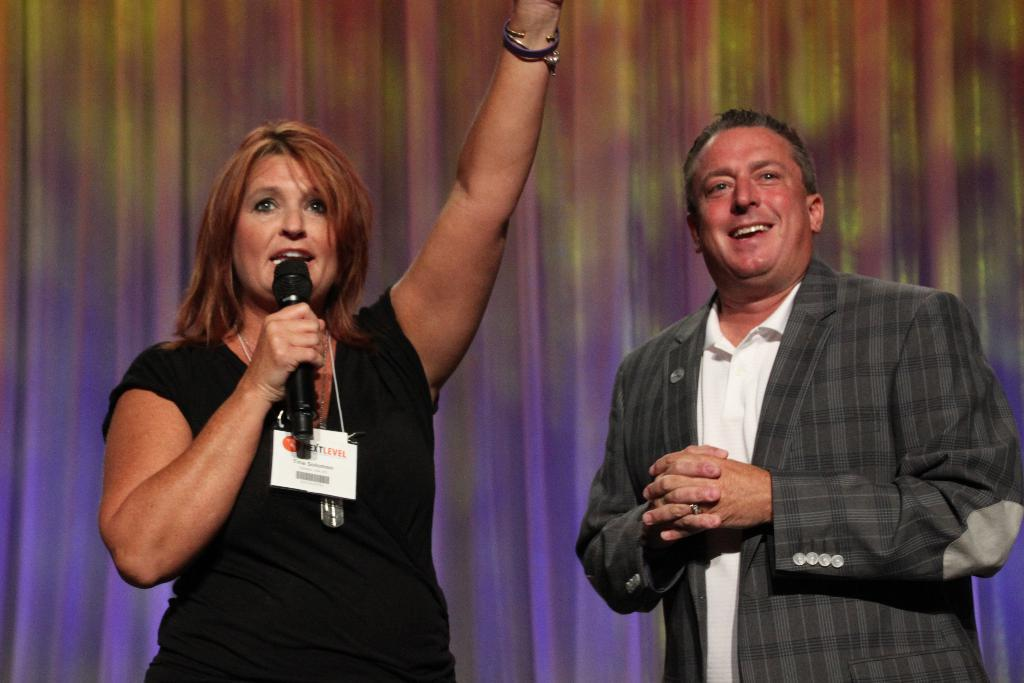What is the gender of the person in the image? There is a woman in the image. What is the woman doing in the image? The woman is standing and talking, holding a microphone in her hand. What is the woman wearing that identifies her? The woman is wearing an ID card. Can you describe the man in the image? The man is standing and smiling. What type of engine is visible in the image? There is no engine present in the image. What territory does the scarecrow protect in the image? There is no scarecrow present in the image. 